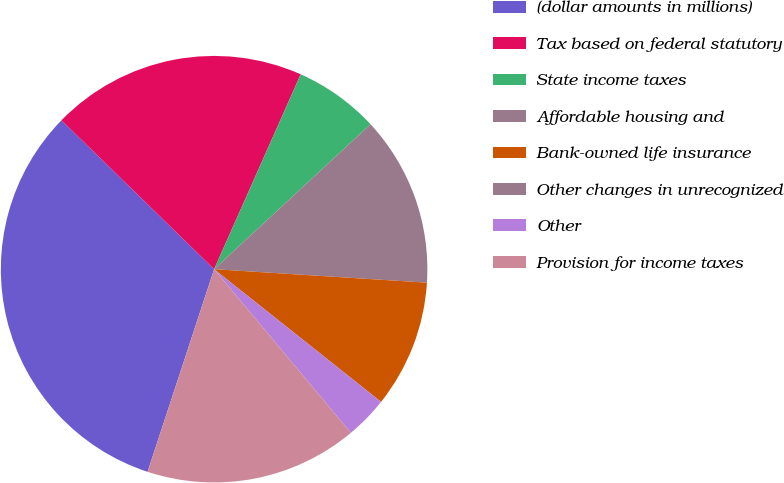<chart> <loc_0><loc_0><loc_500><loc_500><pie_chart><fcel>(dollar amounts in millions)<fcel>Tax based on federal statutory<fcel>State income taxes<fcel>Affordable housing and<fcel>Bank-owned life insurance<fcel>Other changes in unrecognized<fcel>Other<fcel>Provision for income taxes<nl><fcel>32.25%<fcel>19.35%<fcel>6.45%<fcel>12.9%<fcel>9.68%<fcel>0.0%<fcel>3.23%<fcel>16.13%<nl></chart> 